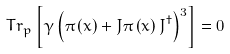Convert formula to latex. <formula><loc_0><loc_0><loc_500><loc_500>T r _ { p } \left [ \gamma \left ( \pi \left ( x \right ) + J \pi \left ( x \right ) J ^ { \dagger } \right ) ^ { 3 } \right ] = 0</formula> 